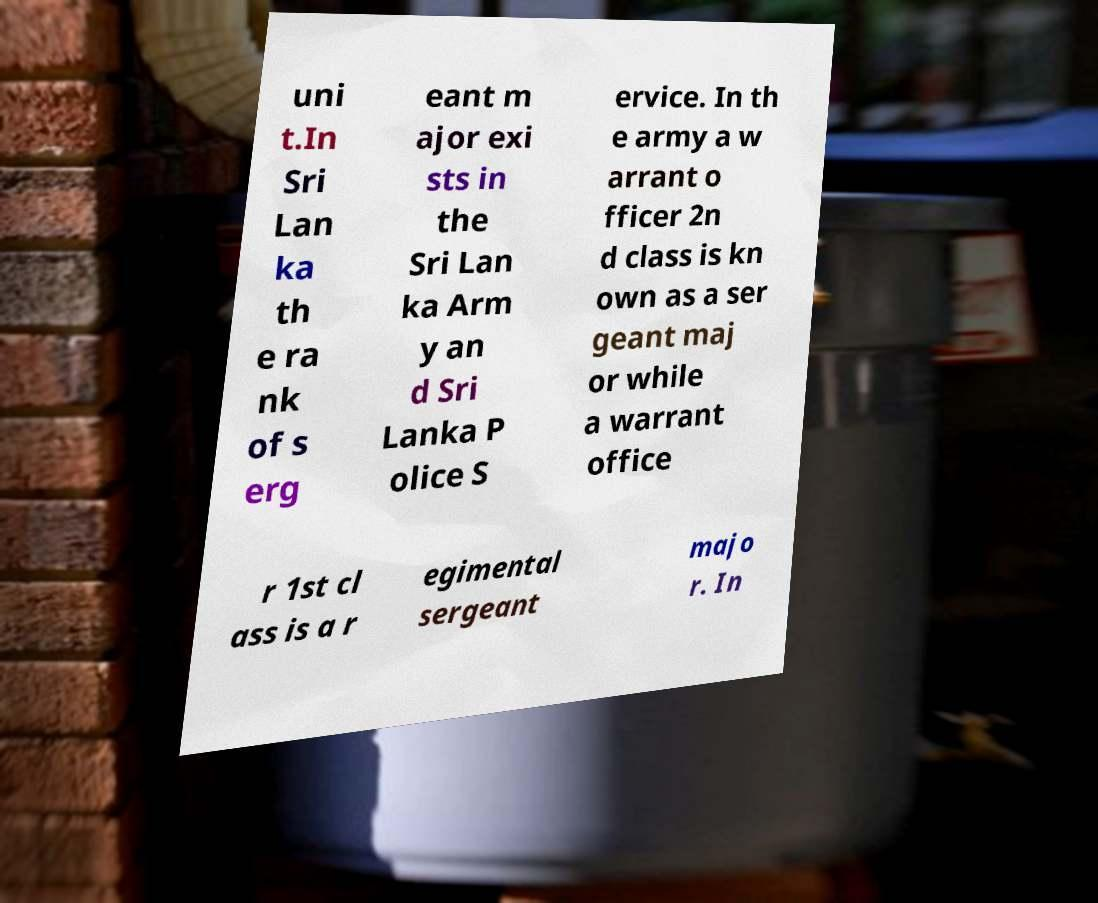Please read and relay the text visible in this image. What does it say? uni t.In Sri Lan ka th e ra nk of s erg eant m ajor exi sts in the Sri Lan ka Arm y an d Sri Lanka P olice S ervice. In th e army a w arrant o fficer 2n d class is kn own as a ser geant maj or while a warrant office r 1st cl ass is a r egimental sergeant majo r. In 